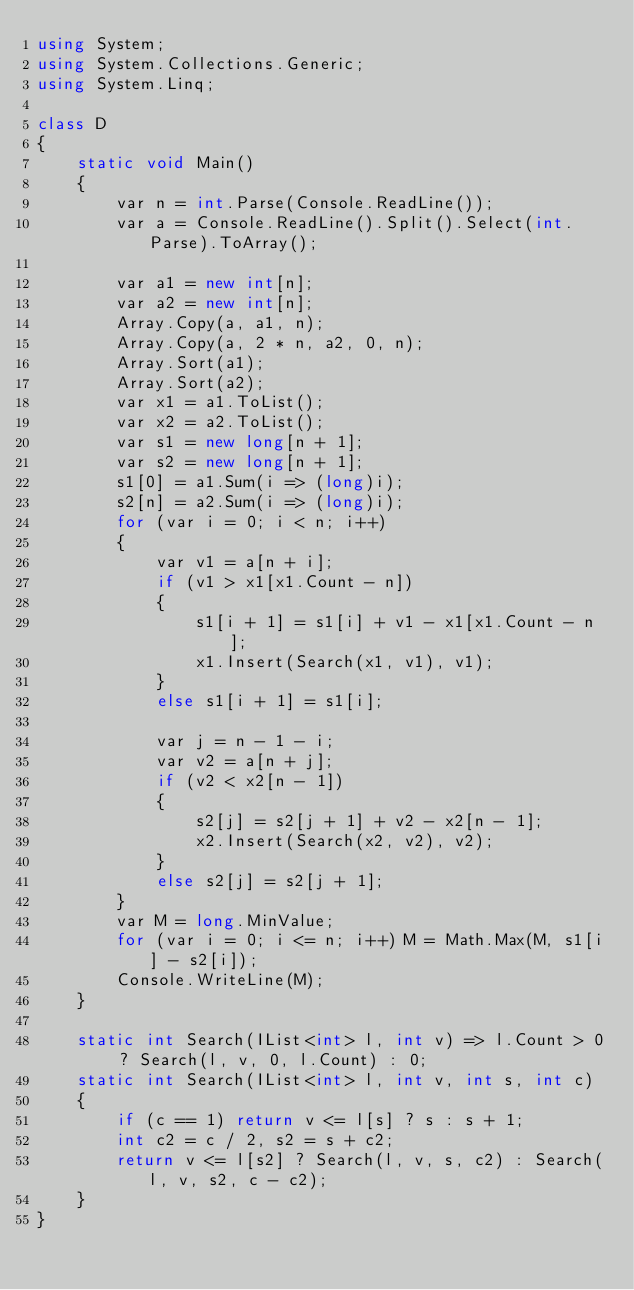<code> <loc_0><loc_0><loc_500><loc_500><_C#_>using System;
using System.Collections.Generic;
using System.Linq;

class D
{
	static void Main()
	{
		var n = int.Parse(Console.ReadLine());
		var a = Console.ReadLine().Split().Select(int.Parse).ToArray();

		var a1 = new int[n];
		var a2 = new int[n];
		Array.Copy(a, a1, n);
		Array.Copy(a, 2 * n, a2, 0, n);
		Array.Sort(a1);
		Array.Sort(a2);
		var x1 = a1.ToList();
		var x2 = a2.ToList();
		var s1 = new long[n + 1];
		var s2 = new long[n + 1];
		s1[0] = a1.Sum(i => (long)i);
		s2[n] = a2.Sum(i => (long)i);
		for (var i = 0; i < n; i++)
		{
			var v1 = a[n + i];
			if (v1 > x1[x1.Count - n])
			{
				s1[i + 1] = s1[i] + v1 - x1[x1.Count - n];
				x1.Insert(Search(x1, v1), v1);
			}
			else s1[i + 1] = s1[i];

			var j = n - 1 - i;
			var v2 = a[n + j];
			if (v2 < x2[n - 1])
			{
				s2[j] = s2[j + 1] + v2 - x2[n - 1];
				x2.Insert(Search(x2, v2), v2);
			}
			else s2[j] = s2[j + 1];
		}
		var M = long.MinValue;
		for (var i = 0; i <= n; i++) M = Math.Max(M, s1[i] - s2[i]);
		Console.WriteLine(M);
	}

	static int Search(IList<int> l, int v) => l.Count > 0 ? Search(l, v, 0, l.Count) : 0;
	static int Search(IList<int> l, int v, int s, int c)
	{
		if (c == 1) return v <= l[s] ? s : s + 1;
		int c2 = c / 2, s2 = s + c2;
		return v <= l[s2] ? Search(l, v, s, c2) : Search(l, v, s2, c - c2);
	}
}
</code> 